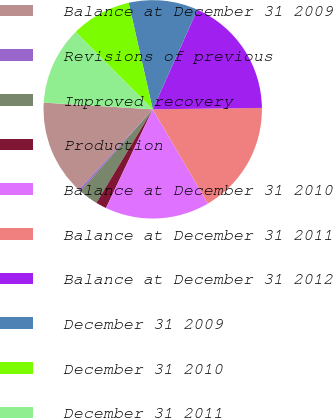Convert chart to OTSL. <chart><loc_0><loc_0><loc_500><loc_500><pie_chart><fcel>Balance at December 31 2009<fcel>Revisions of previous<fcel>Improved recovery<fcel>Production<fcel>Balance at December 31 2010<fcel>Balance at December 31 2011<fcel>Balance at December 31 2012<fcel>December 31 2009<fcel>December 31 2010<fcel>December 31 2011<nl><fcel>14.17%<fcel>0.28%<fcel>2.9%<fcel>1.59%<fcel>15.47%<fcel>16.78%<fcel>18.09%<fcel>10.24%<fcel>8.93%<fcel>11.55%<nl></chart> 